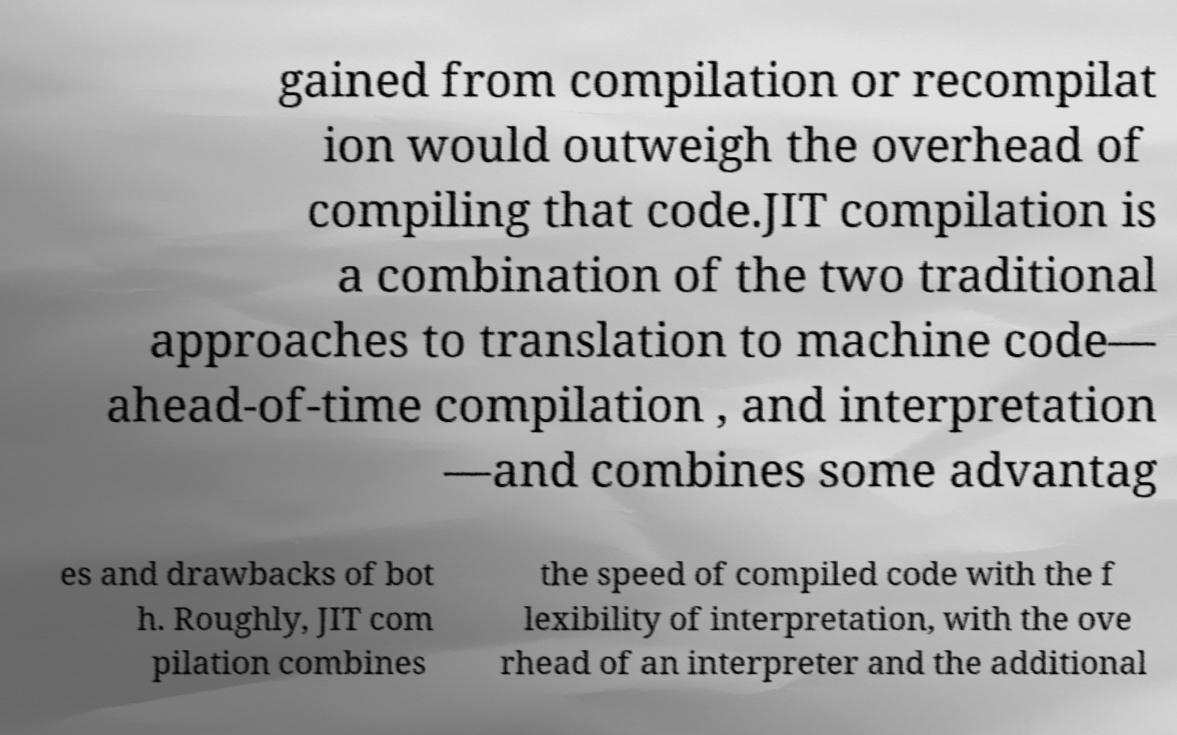I need the written content from this picture converted into text. Can you do that? gained from compilation or recompilat ion would outweigh the overhead of compiling that code.JIT compilation is a combination of the two traditional approaches to translation to machine code— ahead-of-time compilation , and interpretation —and combines some advantag es and drawbacks of bot h. Roughly, JIT com pilation combines the speed of compiled code with the f lexibility of interpretation, with the ove rhead of an interpreter and the additional 